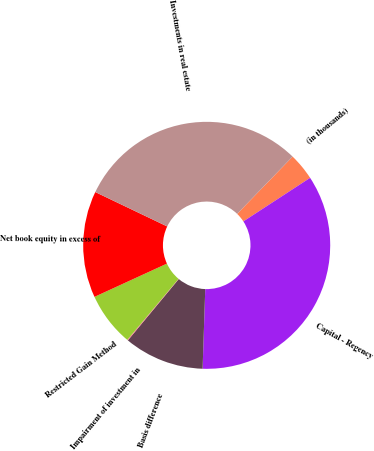Convert chart to OTSL. <chart><loc_0><loc_0><loc_500><loc_500><pie_chart><fcel>(in thousands)<fcel>Capital - Regency<fcel>Basis difference<fcel>Impairment of investment in<fcel>Restricted Gain Method<fcel>Net book equity in excess of<fcel>Investments in real estate<nl><fcel>3.56%<fcel>34.73%<fcel>10.49%<fcel>0.1%<fcel>7.03%<fcel>13.95%<fcel>30.14%<nl></chart> 